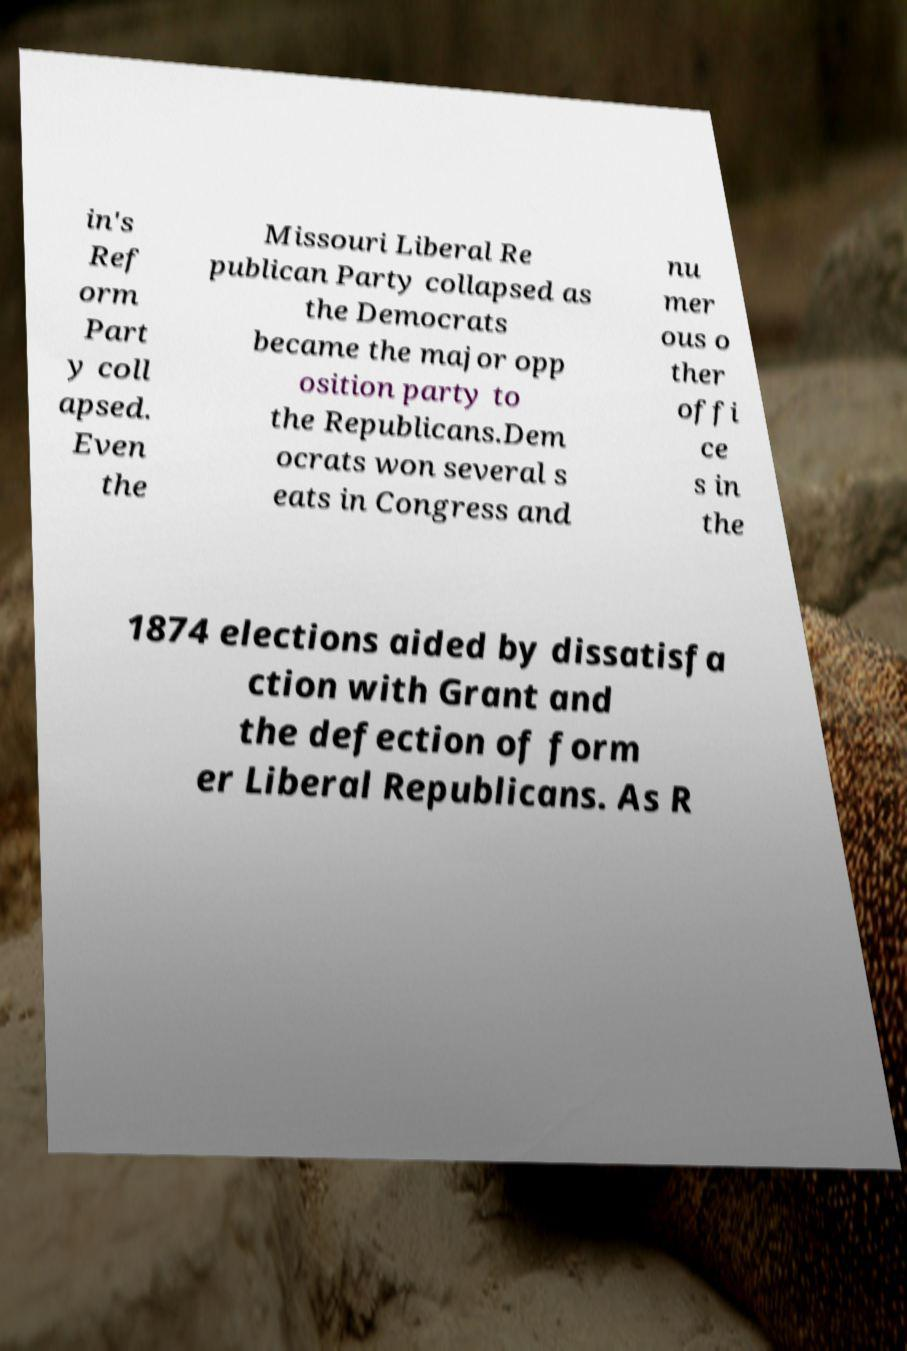Can you accurately transcribe the text from the provided image for me? in's Ref orm Part y coll apsed. Even the Missouri Liberal Re publican Party collapsed as the Democrats became the major opp osition party to the Republicans.Dem ocrats won several s eats in Congress and nu mer ous o ther offi ce s in the 1874 elections aided by dissatisfa ction with Grant and the defection of form er Liberal Republicans. As R 